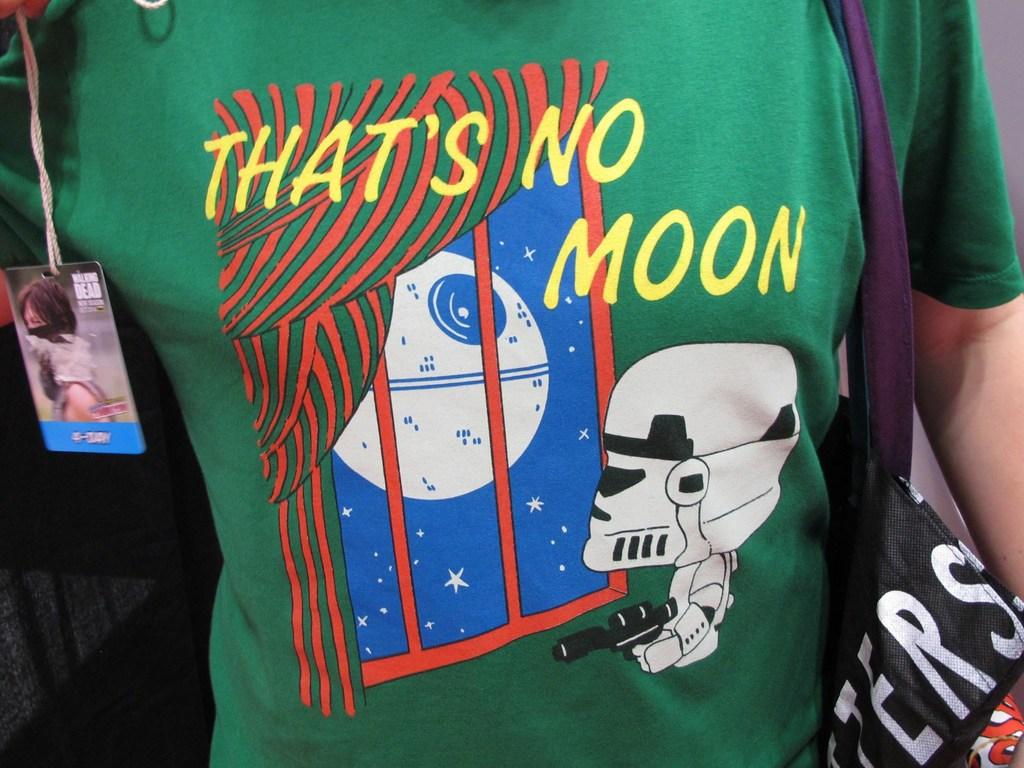What isn't the object in the window, particularly?
Your answer should be very brief. Moon. Is that a giant eyeball?
Ensure brevity in your answer.  Answering does not require reading text in the image. 